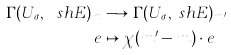<formula> <loc_0><loc_0><loc_500><loc_500>\Gamma ( U _ { \sigma } , \ s h { E } ) _ { m } & \longrightarrow \Gamma ( U _ { \sigma } , \ s h { E } ) _ { m ^ { \prime } } \\ e & \mapsto \chi ( m ^ { \prime } - m ) \cdot e</formula> 